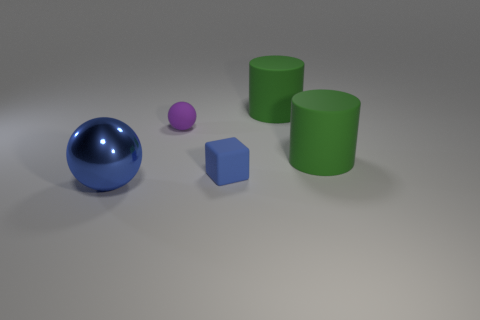Are there any other things that are the same material as the big blue object?
Ensure brevity in your answer.  No. What is the color of the matte object that is the same size as the matte cube?
Your answer should be compact. Purple. Do the thing in front of the tiny blue matte cube and the cube have the same material?
Provide a short and direct response. No. There is a ball behind the thing in front of the rubber block; is there a small matte object that is on the left side of it?
Your answer should be very brief. No. Does the blue object behind the large blue object have the same shape as the blue shiny thing?
Your response must be concise. No. What shape is the small matte object behind the blue object behind the large blue metal object?
Ensure brevity in your answer.  Sphere. What is the size of the purple rubber object in front of the big green rubber object that is left of the green rubber cylinder in front of the purple matte ball?
Keep it short and to the point. Small. There is another object that is the same shape as the tiny purple matte thing; what is its color?
Offer a terse response. Blue. Is the block the same size as the purple matte object?
Provide a short and direct response. Yes. What material is the object that is left of the tiny purple sphere?
Your response must be concise. Metal. 